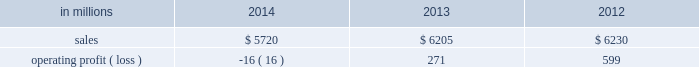Regions .
Principal cost drivers include manufacturing efficiency , raw material and energy costs and freight costs .
Printing papers net sales for 2014 decreased 8% ( 8 % ) to $ 5.7 billion compared with $ 6.2 billion in 2013 and 8% ( 8 % ) compared with $ 6.2 billion in 2012 .
Operating profits in 2014 were 106% ( 106 % ) lower than in 2013 and 103% ( 103 % ) lower than in 2012 .
Excluding facility closure costs , impairment costs and other special items , operating profits in 2014 were 7% ( 7 % ) higher than in 2013 and 8% ( 8 % ) lower than in 2012 .
Benefits from higher average sales price realizations and a favorable mix ( $ 178 million ) , lower planned maintenance downtime costs ( $ 26 million ) , the absence of a provision for bad debt related to a large envelope customer that was booked in 2013 ( $ 28 million ) , and lower foreign exchange and other costs ( $ 25 million ) were offset by lower sales volumes ( $ 82 million ) , higher operating costs ( $ 49 million ) , higher input costs ( $ 47 million ) , and costs associated with the closure of our courtland , alabama mill ( $ 41 million ) .
In addition , operating profits in 2014 include special items costs of $ 554 million associated with the closure of our courtland , alabama mill .
During 2013 , the company accelerated depreciation for certain courtland assets , and evaluated certain other assets for possible alternative uses by one of our other businesses .
The net book value of these assets at december 31 , 2013 was approximately $ 470 million .
In the first quarter of 2014 , we completed our evaluation and concluded that there were no alternative uses for these assets .
We recognized approximately $ 464 million of accelerated depreciation related to these assets in 2014 .
Operating profits in 2014 also include a charge of $ 32 million associated with a foreign tax amnesty program , and a gain of $ 20 million for the resolution of a legal contingency in india , while operating profits in 2013 included costs of $ 118 million associated with the announced closure of our courtland , alabama mill and a $ 123 million impairment charge associated with goodwill and a trade name intangible asset in our india papers business .
Printing papers .
North american printing papers net sales were $ 2.1 billion in 2014 , $ 2.6 billion in 2013 and $ 2.7 billion in 2012 .
Operating profits in 2014 were a loss of $ 398 million ( a gain of $ 156 million excluding costs associated with the shutdown of our courtland , alabama mill ) compared with gains of $ 36 million ( $ 154 million excluding costs associated with the courtland mill shutdown ) in 2013 and $ 331 million in 2012 .
Sales volumes in 2014 decreased compared with 2013 due to lower market demand for uncoated freesheet paper and the closure our courtland mill .
Average sales price realizations were higher , reflecting sales price increases in both domestic and export markets .
Higher input costs for wood were offset by lower costs for chemicals , however freight costs were higher .
Planned maintenance downtime costs were $ 14 million lower in 2014 .
Operating profits in 2014 were negatively impacted by costs associated with the shutdown of our courtland , alabama mill but benefited from the absence of a provision for bad debt related to a large envelope customer that was recorded in 2013 .
Entering the first quarter of 2015 , sales volumes are expected to be stable compared with the fourth quarter of 2014 .
Average sales margins should improve reflecting a more favorable mix although average sales price realizations are expected to be flat .
Input costs are expected to be stable .
Planned maintenance downtime costs are expected to be about $ 16 million lower with an outage scheduled in the 2015 first quarter at our georgetown mill compared with outages at our eastover and riverdale mills in the 2014 fourth quarter .
Brazilian papers net sales for 2014 were $ 1.1 billion compared with $ 1.1 billion in 2013 and $ 1.1 billion in 2012 .
Operating profits for 2014 were $ 177 million ( $ 209 million excluding costs associated with a tax amnesty program ) compared with $ 210 million in 2013 and $ 163 million in 2012 .
Sales volumes in 2014 were about flat compared with 2013 .
Average sales price realizations improved for domestic uncoated freesheet paper due to the realization of price increases implemented in the second half of 2013 and in 2014 .
Margins were favorably affected by an increased proportion of sales to the higher-margin domestic market .
Raw material costs increased for wood and chemicals .
Operating costs were higher than in 2013 and planned maintenance downtime costs were flat .
Looking ahead to 2015 , sales volumes in the first quarter are expected to decrease due to seasonally weaker customer demand for uncoated freesheet paper .
Average sales price improvements are expected to reflect the partial realization of announced sales price increases in the brazilian domestic market for uncoated freesheet paper .
Input costs are expected to be flat .
Planned maintenance outage costs should be $ 5 million lower with an outage scheduled at the luiz antonio mill in the first quarter .
European papers net sales in 2014 were $ 1.5 billion compared with $ 1.5 billion in 2013 and $ 1.4 billion in 2012 .
Operating profits in 2014 were $ 140 million compared with $ 167 million in 2013 and $ 179 million in compared with 2013 , sales volumes for uncoated freesheet paper in 2014 were slightly higher in both .
In 2013 what was printing papers operating margin? 
Computations: (271 / 6205)
Answer: 0.04367. 